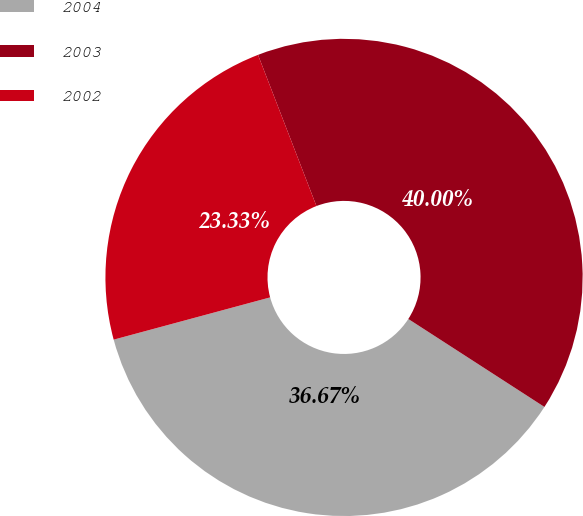<chart> <loc_0><loc_0><loc_500><loc_500><pie_chart><fcel>2004<fcel>2003<fcel>2002<nl><fcel>36.67%<fcel>40.0%<fcel>23.33%<nl></chart> 